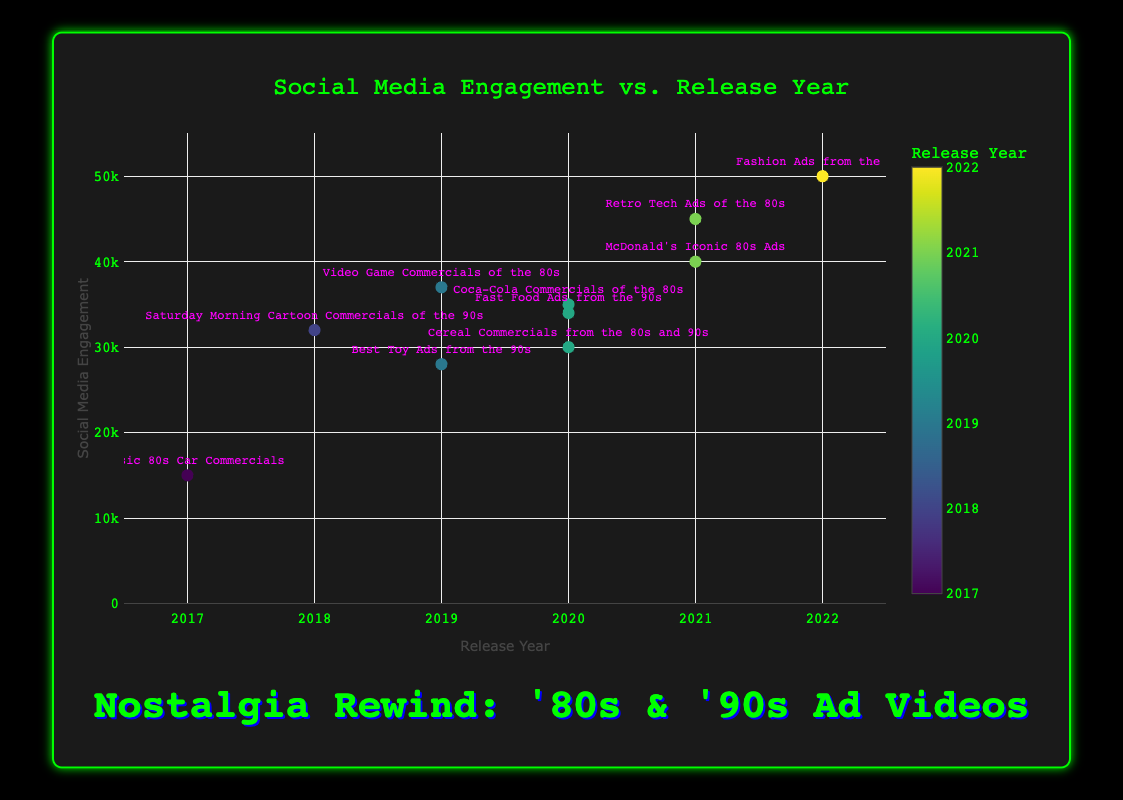How do the social media engagements for videos released in 2021 compare to those released in 2020? To compare the social media engagements, look at each video’s release year and corresponding engagement. For 2021, "McDonald's Iconic 80s Ads" has 40000 engagements, and "Retro Tech Ads of the 80s" has 45000 engagements. For 2020, "Coca-Cola Commercials of the 80s" has 35000 engagements, "Cereal Commercials from the 80s and 90s" has 30000 engagements, and "Fast Food Ads from the 90s" has 34000 engagements. Now compare each engagement:
2021: 40000, 45000
2020: 35000, 30000, 34000
Engagements for 2021 are generally higher than those for 2020.
Answer: Higher in 2021 Which video has the highest social media engagement? To find the highest social media engagement, identify the maximum value on the y-axis. The text above the highest point will give the video title. "Fashion Ads from the 90s" stands at the highest point with an engagement of 50000.
Answer: Fashion Ads from the 90s What is the median social media engagement value for all the videos? List all social media engagement values: 15000, 28000, 30000, 32000, 34000, 35000, 37000, 40000, 45000, 50000. 
Order them: 15000, 28000, 30000, 32000, 34000, 35000, 37000, 40000, 45000, 50000.
With 10 data points, the median is the average of the 5th and 6th values: 
(34000 + 35000) / 2 = 34500.
Answer: 34500 What's the difference in social media engagement between the video with the highest and the video with the lowest engagement? Identify the highest (50000) and lowest (15000) engagements from the y-axis. 
Difference: 50000 - 15000 = 35000.
Answer: 35000 Are there more videos released before or after 2020? Count the videos on either side of 2020. Before: 2017 (1), 2018 (1), 2019 (2). Total = 4.
After: 2020 (3), 2021 (2), 2022 (1). Total = 6. 
There are more videos released after 2020.
Answer: After Which year has the highest average social media engagement for the videos released in that year? Calculate the average engagement for each year:
2017: 15000
2018: 32000
2019: (28000 + 37000) / 2 = 32500
2020: (35000 + 30000 + 34000) / 3 = 33000
2021: (40000 + 45000) / 2 = 42500
2022: 50000
The highest average is for 2022.
Answer: 2022 